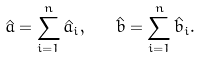Convert formula to latex. <formula><loc_0><loc_0><loc_500><loc_500>\hat { a } = \sum _ { i = 1 } ^ { n } \hat { a } _ { i } , \quad \hat { b } = \sum _ { i = 1 } ^ { n } \hat { b } _ { i } .</formula> 